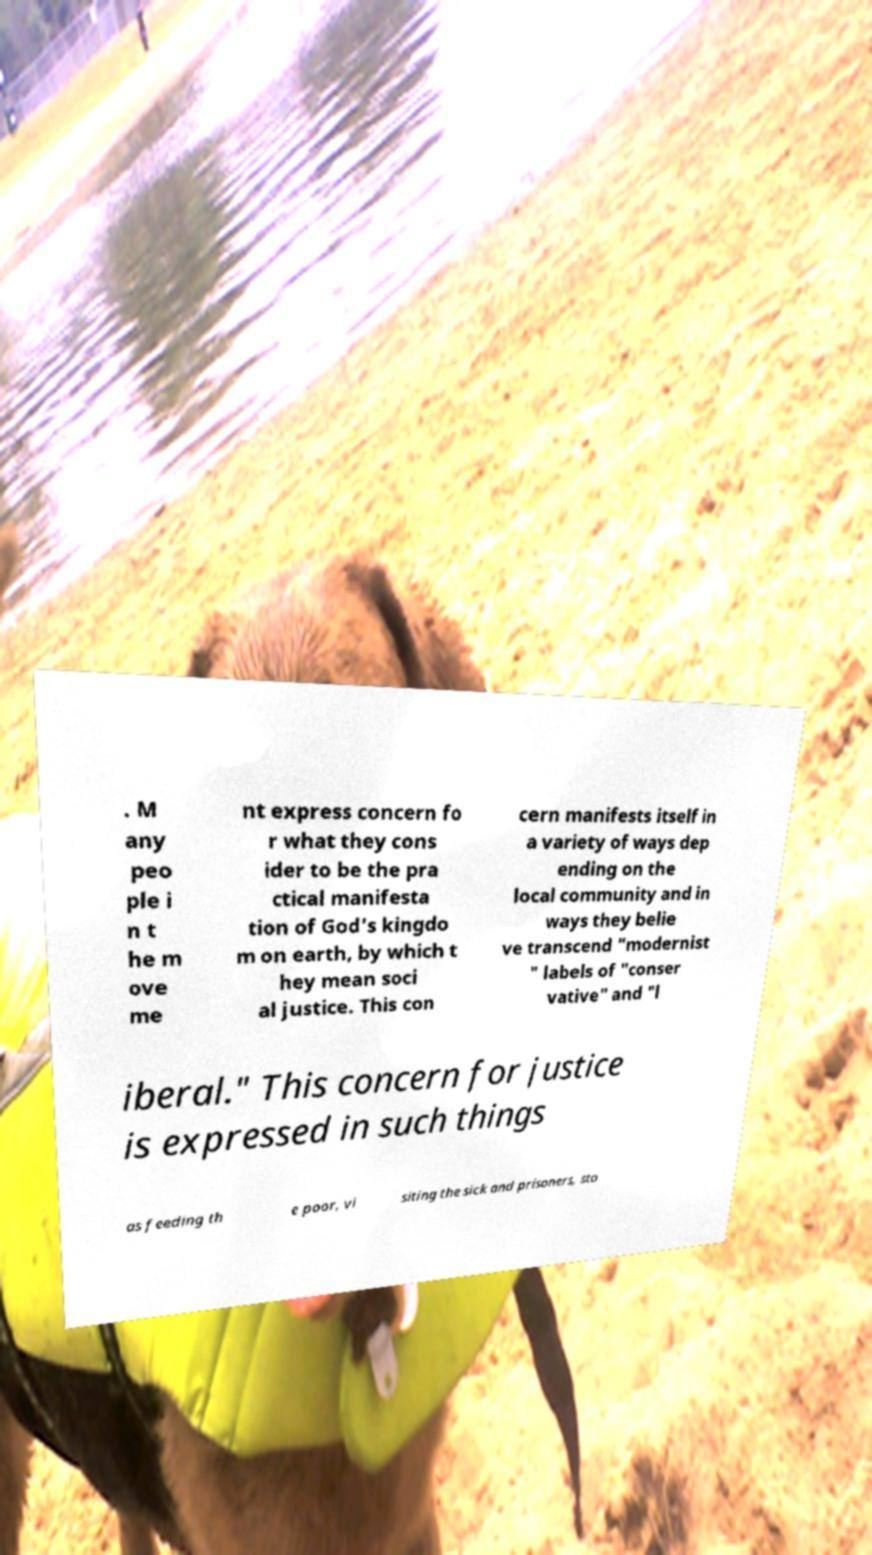Could you assist in decoding the text presented in this image and type it out clearly? . M any peo ple i n t he m ove me nt express concern fo r what they cons ider to be the pra ctical manifesta tion of God's kingdo m on earth, by which t hey mean soci al justice. This con cern manifests itself in a variety of ways dep ending on the local community and in ways they belie ve transcend "modernist " labels of "conser vative" and "l iberal." This concern for justice is expressed in such things as feeding th e poor, vi siting the sick and prisoners, sto 